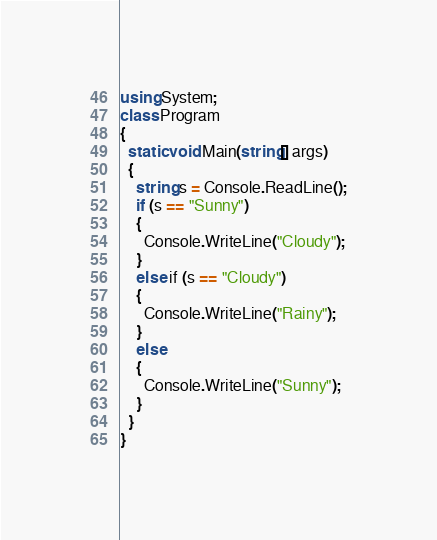Convert code to text. <code><loc_0><loc_0><loc_500><loc_500><_C#_>using System;
class Program
{
  static void Main(string[] args)
  {
    string s = Console.ReadLine();
    if (s == "Sunny")
    {
      Console.WriteLine("Cloudy");
    }
    else if (s == "Cloudy")
    {
      Console.WriteLine("Rainy");
    }
    else
    {
      Console.WriteLine("Sunny");
    }
  }
}</code> 